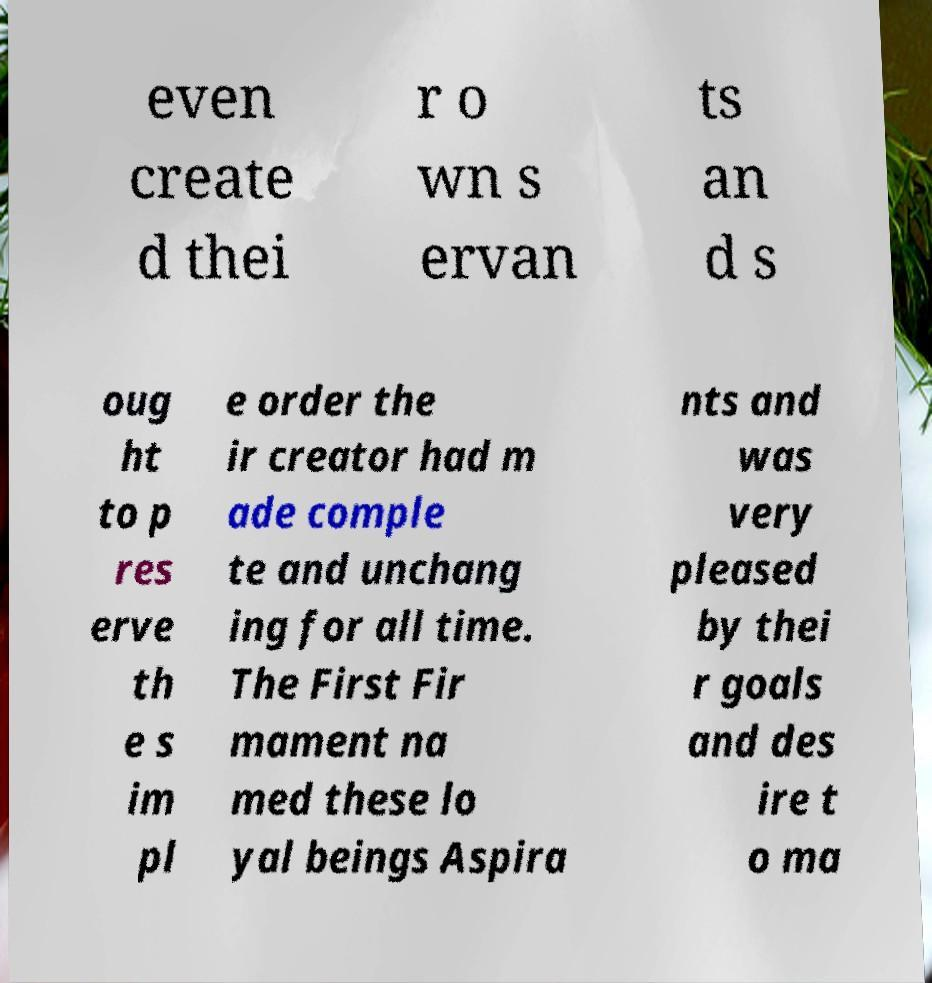Could you extract and type out the text from this image? even create d thei r o wn s ervan ts an d s oug ht to p res erve th e s im pl e order the ir creator had m ade comple te and unchang ing for all time. The First Fir mament na med these lo yal beings Aspira nts and was very pleased by thei r goals and des ire t o ma 